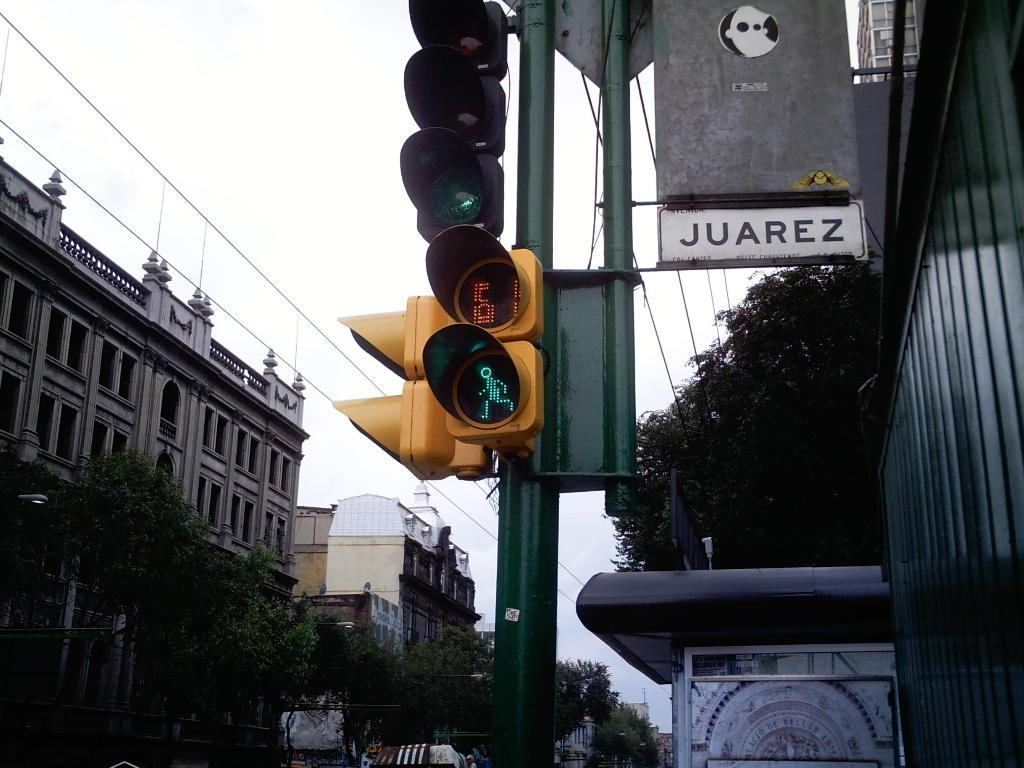<image>
Offer a succinct explanation of the picture presented. a sign that has the word Juarez on it 